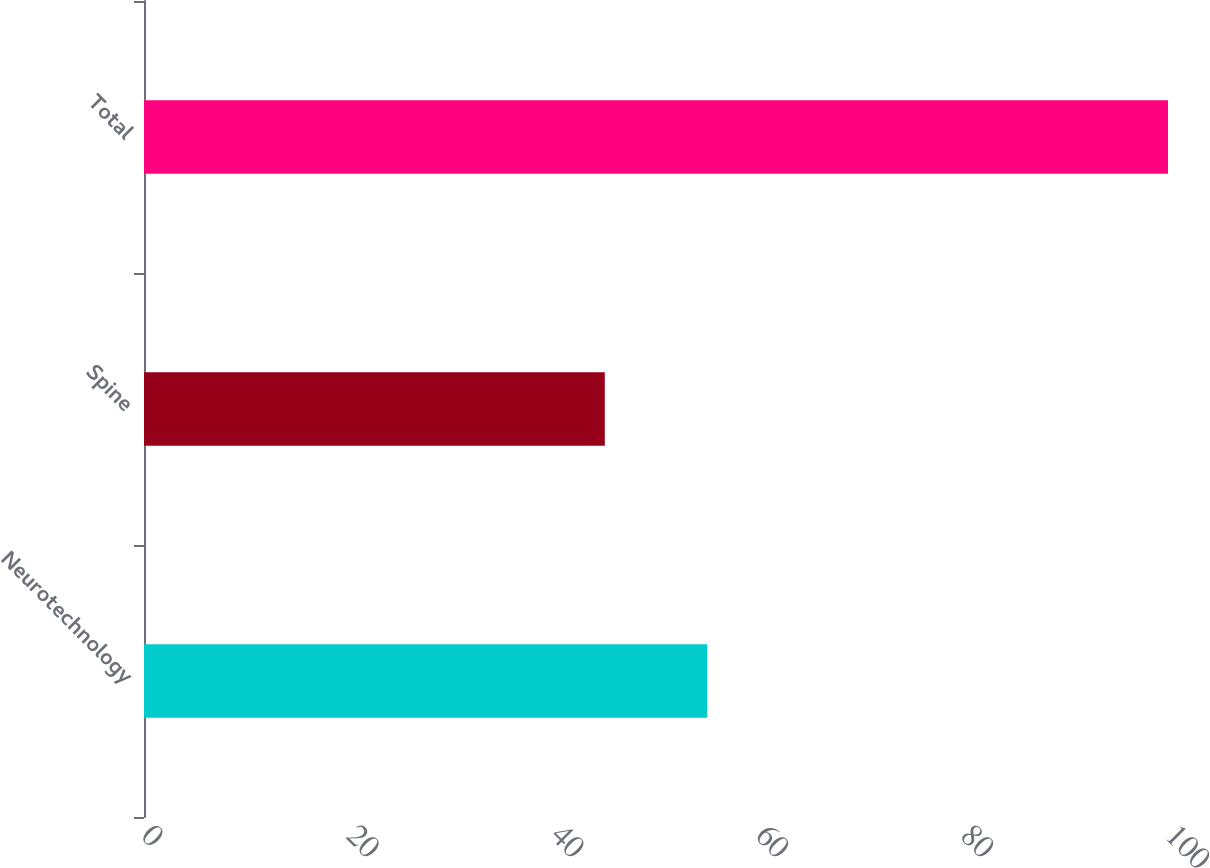<chart> <loc_0><loc_0><loc_500><loc_500><bar_chart><fcel>Neurotechnology<fcel>Spine<fcel>Total<nl><fcel>55<fcel>45<fcel>100<nl></chart> 